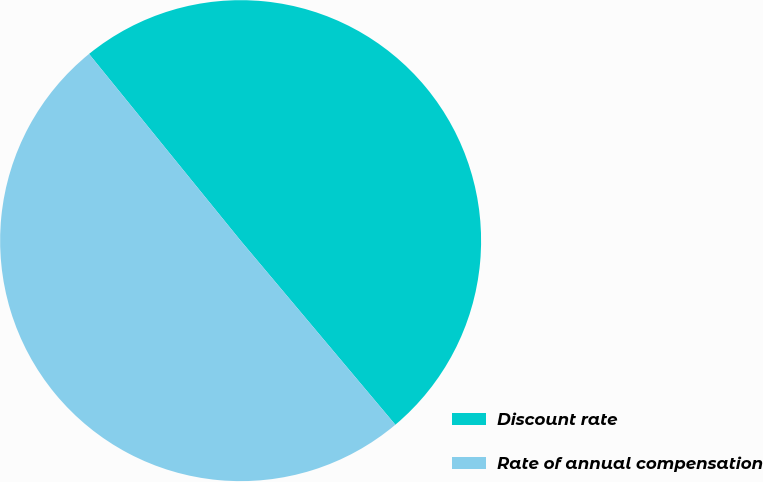Convert chart to OTSL. <chart><loc_0><loc_0><loc_500><loc_500><pie_chart><fcel>Discount rate<fcel>Rate of annual compensation<nl><fcel>49.73%<fcel>50.27%<nl></chart> 